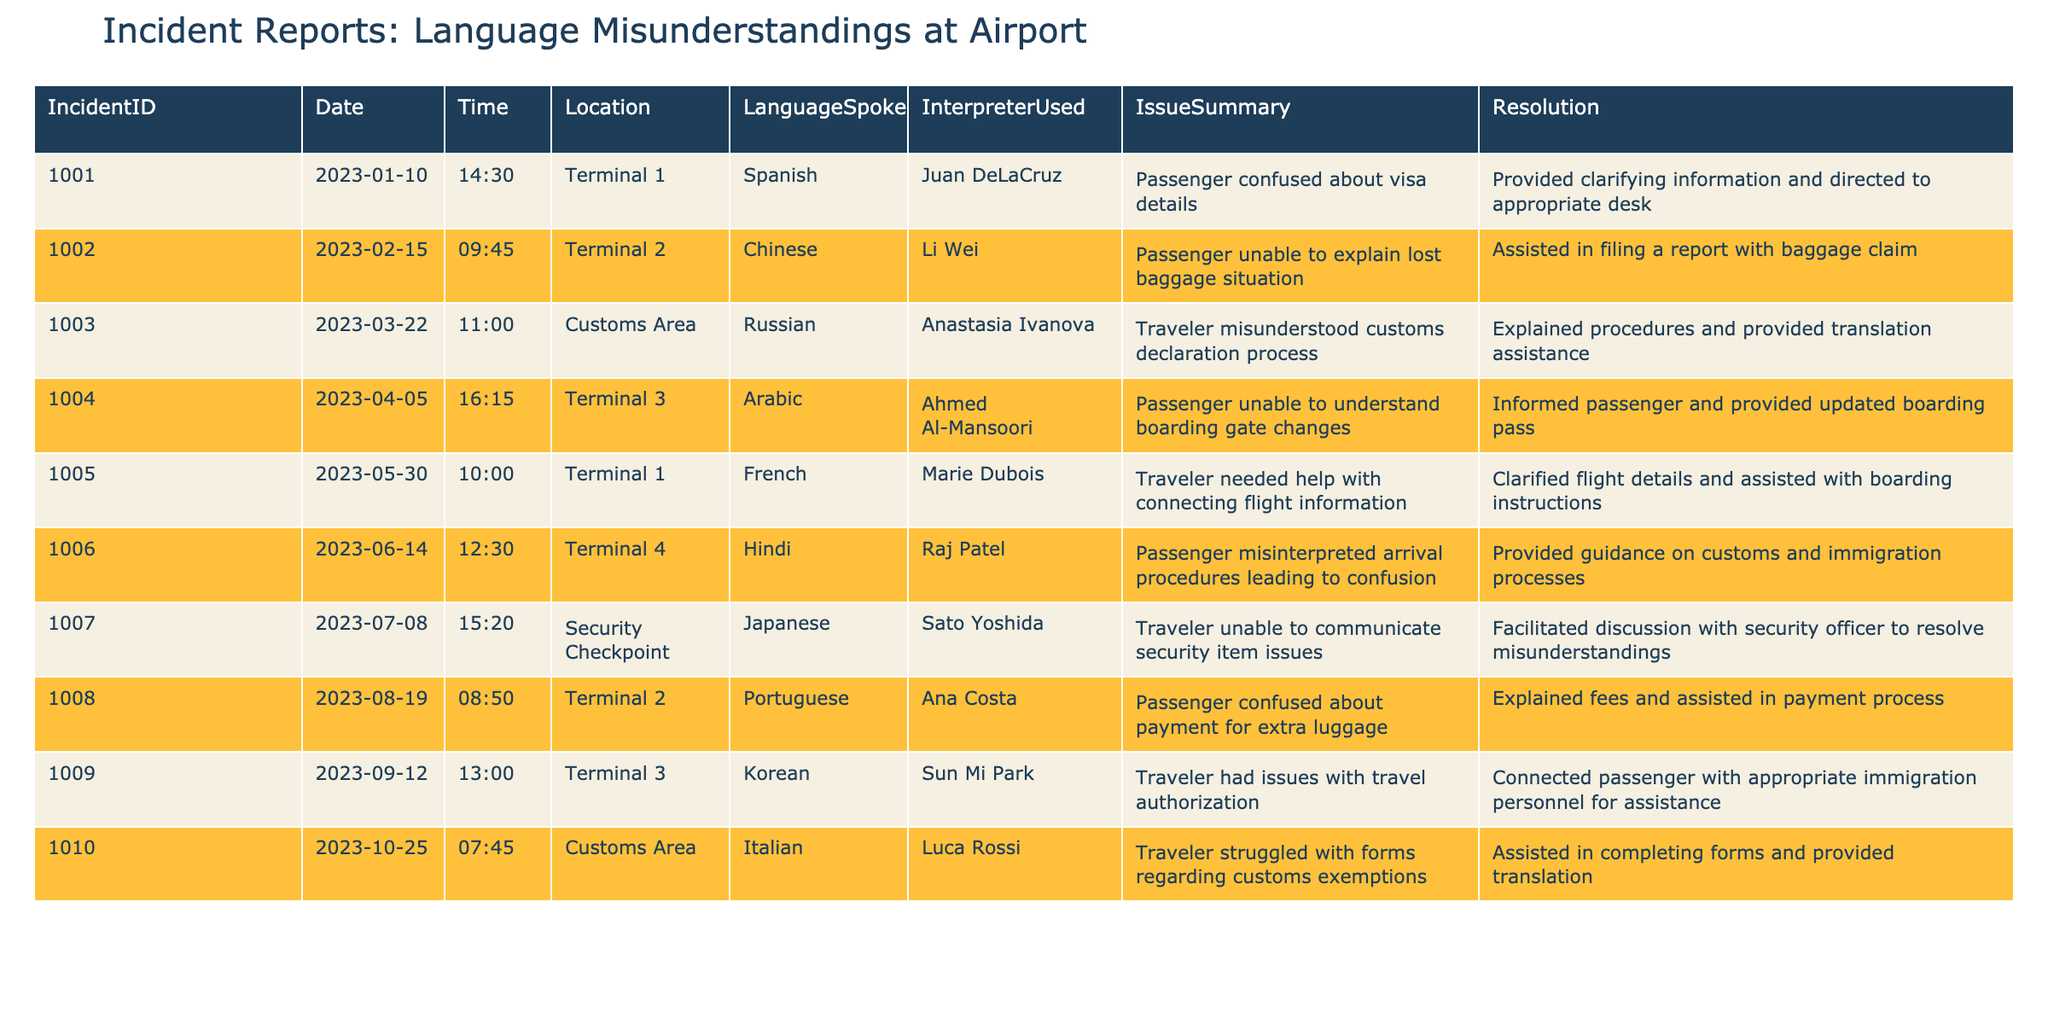What language was spoken in incident report 1004? In the table, we can find incident report 1004, which lists the 'LanguageSpoken' column. For this specific incident, the language spoken is 'Arabic'.
Answer: Arabic How many incidents involved the use of an interpreter? By looking at the 'InterpreterUsed' column, we can see there are 10 incident reports total, and all of them indicate an interpreter was used. Therefore, the number of incidents involving an interpreter is 10.
Answer: 10 Which incident report had a resolution related to customs exemptions? Reviewing the 'Resolution' column, we find that incident report 1010 mentions assistance with customs exemptions. Hence, the incident report related to customs exemptions is 1010.
Answer: 1010 Did any incident reports involve confusion about baggage claims? By examining the 'IssueSummary' column, incident report 1002 specifically mentions a lost baggage situation which led to confusion. Thus, the answer to whether any incidents involved baggage claims is yes.
Answer: Yes What was the most frequent location of incidents where language misunderstandings occurred? By tallying the locations listed in the 'Location' column, we see 'Terminal 1' is mentioned twice (in incidents 1001 and 1005), while other locations only appear once. This makes 'Terminal 1' the most frequent incident location related to language misunderstandings.
Answer: Terminal 1 Which language was associated with the incident report that mentioned confusion about boarding gate changes? In incident report 1004, the 'LanguageSpoken' column indicates 'Arabic', which was the language spoken by the passenger who had confusion about boarding gate changes.
Answer: Arabic How many incidents involved a resolution that included clarifying information or assistance? Looking at the 'Resolution' column, we check each incident report: all 10 reports involved some form of clarifying information or assistance. Thus, the total count of such incidents is 10.
Answer: 10 Was there an incident where the interpretation was provided at the customs area? Yes, by checking the 'Location' column, we see that incident reports 1003 and 1010 both occurred in the Customs Area, confirming there were incidents with interpretation provided there.
Answer: Yes What is the total number of incidents occurring in Terminal 2? From the 'Location' column, we can identify that there are two incidents – 1002 and 1008 – that occurred in Terminal 2. Thus, the total count of incidents in Terminal 2 is 2.
Answer: 2 